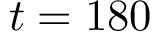Convert formula to latex. <formula><loc_0><loc_0><loc_500><loc_500>t = 1 8 0</formula> 